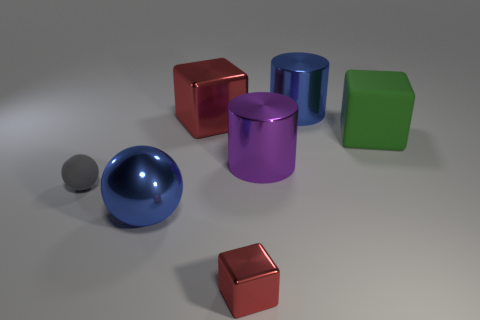Subtract all large red blocks. How many blocks are left? 2 Subtract all purple cylinders. How many red cubes are left? 2 Subtract all green cubes. How many cubes are left? 2 Add 1 large cyan shiny cylinders. How many objects exist? 8 Subtract all purple balls. Subtract all brown cubes. How many balls are left? 2 Subtract all blue metal balls. Subtract all big blue metal objects. How many objects are left? 4 Add 4 big shiny things. How many big shiny things are left? 8 Add 4 big green spheres. How many big green spheres exist? 4 Subtract 1 purple cylinders. How many objects are left? 6 Subtract all blocks. How many objects are left? 4 